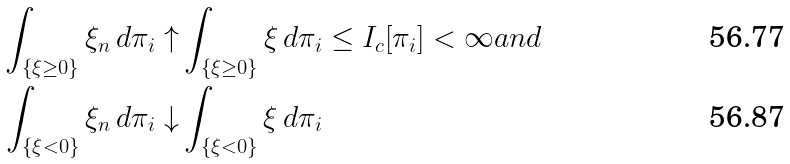Convert formula to latex. <formula><loc_0><loc_0><loc_500><loc_500>\int _ { \{ \xi \geq 0 \} } \xi _ { n } \, d \pi _ { i } \uparrow & \int _ { \{ \xi \geq 0 \} } \xi \, d \pi _ { i } \leq I _ { c } [ \pi _ { i } ] < \infty a n d \\ \int _ { \{ \xi < 0 \} } \xi _ { n } \, d \pi _ { i } \downarrow & \int _ { \{ \xi < 0 \} } \xi \, d \pi _ { i }</formula> 